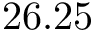<formula> <loc_0><loc_0><loc_500><loc_500>2 6 . 2 5</formula> 